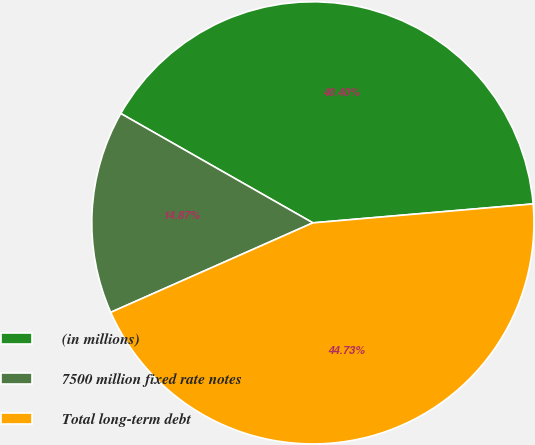Convert chart. <chart><loc_0><loc_0><loc_500><loc_500><pie_chart><fcel>(in millions)<fcel>7500 million fixed rate notes<fcel>Total long-term debt<nl><fcel>40.4%<fcel>14.87%<fcel>44.73%<nl></chart> 